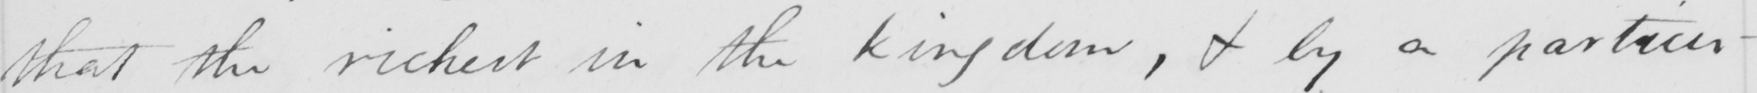What is written in this line of handwriting? that the richest in the kingdom , & by a particu- 